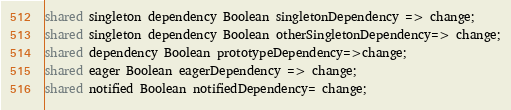<code> <loc_0><loc_0><loc_500><loc_500><_Ceylon_>shared singleton dependency Boolean singletonDependency => change;
shared singleton dependency Boolean otherSingletonDependency=> change;
shared dependency Boolean prototypeDependency=>change;
shared eager Boolean eagerDependency => change;
shared notified Boolean notifiedDependency= change;</code> 